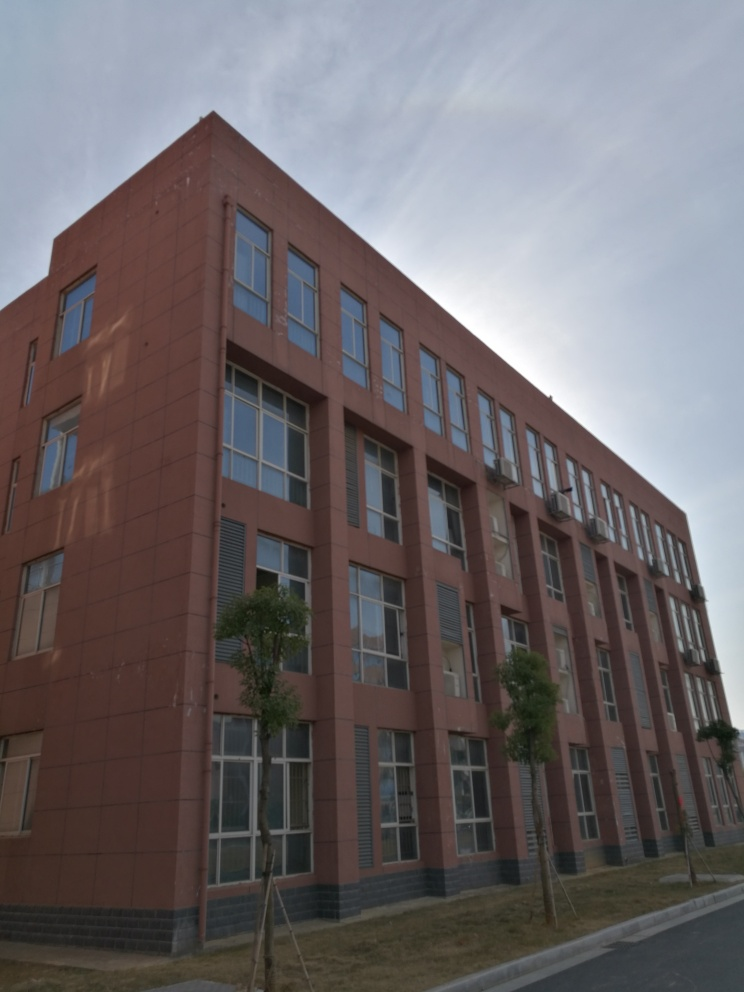Can you suggest some ways to enhance this photo? To enhance this photo, one could adjust the exposure to brighten the shadows, increase the contrast slightly to make the image pop, and apply sharpening to bring out more detail in the building's facade. Additionally, cropping the image to align with the rule of thirds could help balance the composition. 